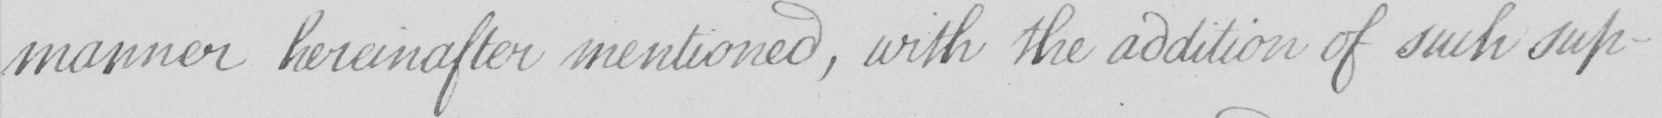What text is written in this handwritten line? manner hereinafter mentioned , with the addition of such sup- 